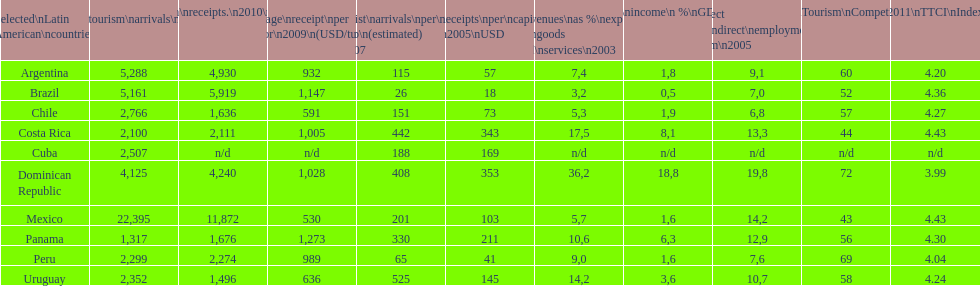How does brazil rank in average receipts per visitor in 2009? 1,147. 